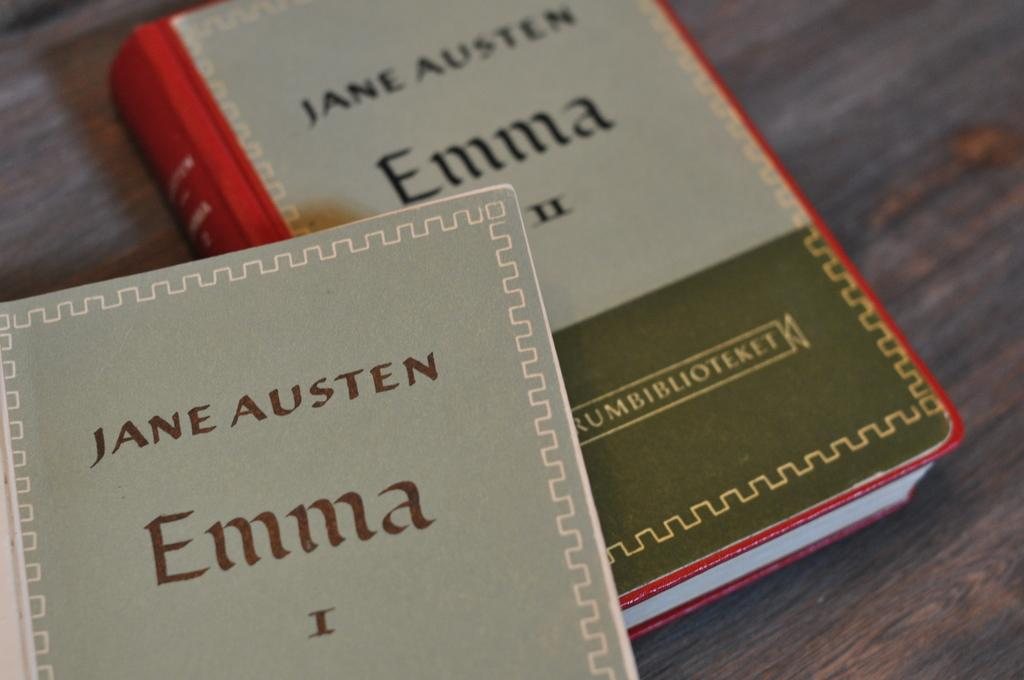<image>
Summarize the visual content of the image. Jane Austen wrote a series of novels called Emma. 